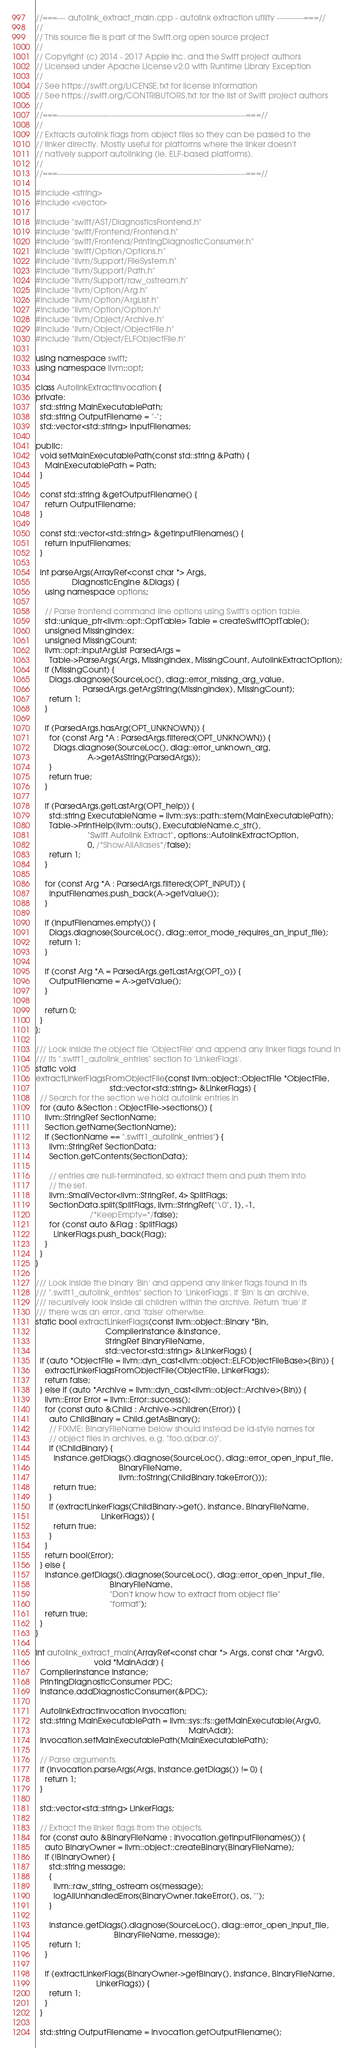Convert code to text. <code><loc_0><loc_0><loc_500><loc_500><_C++_>//===--- autolink_extract_main.cpp - autolink extraction utility ----------===//
//
// This source file is part of the Swift.org open source project
//
// Copyright (c) 2014 - 2017 Apple Inc. and the Swift project authors
// Licensed under Apache License v2.0 with Runtime Library Exception
//
// See https://swift.org/LICENSE.txt for license information
// See https://swift.org/CONTRIBUTORS.txt for the list of Swift project authors
//
//===----------------------------------------------------------------------===//
//
// Extracts autolink flags from object files so they can be passed to the
// linker directly. Mostly useful for platforms where the linker doesn't
// natively support autolinking (ie. ELF-based platforms).
//
//===----------------------------------------------------------------------===//

#include <string>
#include <vector>

#include "swift/AST/DiagnosticsFrontend.h"
#include "swift/Frontend/Frontend.h"
#include "swift/Frontend/PrintingDiagnosticConsumer.h"
#include "swift/Option/Options.h"
#include "llvm/Support/FileSystem.h"
#include "llvm/Support/Path.h"
#include "llvm/Support/raw_ostream.h"
#include "llvm/Option/Arg.h"
#include "llvm/Option/ArgList.h"
#include "llvm/Option/Option.h"
#include "llvm/Object/Archive.h"
#include "llvm/Object/ObjectFile.h"
#include "llvm/Object/ELFObjectFile.h"

using namespace swift;
using namespace llvm::opt;

class AutolinkExtractInvocation {
private:
  std::string MainExecutablePath;
  std::string OutputFilename = "-";
  std::vector<std::string> InputFilenames;

public:
  void setMainExecutablePath(const std::string &Path) {
    MainExecutablePath = Path;
  }

  const std::string &getOutputFilename() {
    return OutputFilename;
  }

  const std::vector<std::string> &getInputFilenames() {
    return InputFilenames;
  }

  int parseArgs(ArrayRef<const char *> Args,
                DiagnosticEngine &Diags) {
    using namespace options;

    // Parse frontend command line options using Swift's option table.
    std::unique_ptr<llvm::opt::OptTable> Table = createSwiftOptTable();
    unsigned MissingIndex;
    unsigned MissingCount;
    llvm::opt::InputArgList ParsedArgs =
      Table->ParseArgs(Args, MissingIndex, MissingCount, AutolinkExtractOption);
    if (MissingCount) {
      Diags.diagnose(SourceLoc(), diag::error_missing_arg_value,
                     ParsedArgs.getArgString(MissingIndex), MissingCount);
      return 1;
    }

    if (ParsedArgs.hasArg(OPT_UNKNOWN)) {
      for (const Arg *A : ParsedArgs.filtered(OPT_UNKNOWN)) {
        Diags.diagnose(SourceLoc(), diag::error_unknown_arg,
                       A->getAsString(ParsedArgs));
      }
      return true;
    }

    if (ParsedArgs.getLastArg(OPT_help)) {
      std::string ExecutableName = llvm::sys::path::stem(MainExecutablePath);
      Table->PrintHelp(llvm::outs(), ExecutableName.c_str(),
                       "Swift Autolink Extract", options::AutolinkExtractOption,
                       0, /*ShowAllAliases*/false);
      return 1;
    }

    for (const Arg *A : ParsedArgs.filtered(OPT_INPUT)) {
      InputFilenames.push_back(A->getValue());
    }

    if (InputFilenames.empty()) {
      Diags.diagnose(SourceLoc(), diag::error_mode_requires_an_input_file);
      return 1;
    }

    if (const Arg *A = ParsedArgs.getLastArg(OPT_o)) {
      OutputFilename = A->getValue();
    }

    return 0;
  }
};

/// Look inside the object file 'ObjectFile' and append any linker flags found in
/// its ".swift1_autolink_entries" section to 'LinkerFlags'.
static void
extractLinkerFlagsFromObjectFile(const llvm::object::ObjectFile *ObjectFile,
                                 std::vector<std::string> &LinkerFlags) {
  // Search for the section we hold autolink entries in
  for (auto &Section : ObjectFile->sections()) {
    llvm::StringRef SectionName;
    Section.getName(SectionName);
    if (SectionName == ".swift1_autolink_entries") {
      llvm::StringRef SectionData;
      Section.getContents(SectionData);

      // entries are null-terminated, so extract them and push them into
      // the set.
      llvm::SmallVector<llvm::StringRef, 4> SplitFlags;
      SectionData.split(SplitFlags, llvm::StringRef("\0", 1), -1,
                        /*KeepEmpty=*/false);
      for (const auto &Flag : SplitFlags)
        LinkerFlags.push_back(Flag);
    }
  }
}

/// Look inside the binary 'Bin' and append any linker flags found in its
/// ".swift1_autolink_entries" section to 'LinkerFlags'. If 'Bin' is an archive,
/// recursively look inside all children within the archive. Return 'true' if
/// there was an error, and 'false' otherwise.
static bool extractLinkerFlags(const llvm::object::Binary *Bin,
                               CompilerInstance &Instance,
                               StringRef BinaryFileName,
                               std::vector<std::string> &LinkerFlags) {
  if (auto *ObjectFile = llvm::dyn_cast<llvm::object::ELFObjectFileBase>(Bin)) {
    extractLinkerFlagsFromObjectFile(ObjectFile, LinkerFlags);
    return false;
  } else if (auto *Archive = llvm::dyn_cast<llvm::object::Archive>(Bin)) {
    llvm::Error Error = llvm::Error::success();
    for (const auto &Child : Archive->children(Error)) {
      auto ChildBinary = Child.getAsBinary();
      // FIXME: BinaryFileName below should instead be ld-style names for
      // object files in archives, e.g. "foo.a(bar.o)".
      if (!ChildBinary) {
        Instance.getDiags().diagnose(SourceLoc(), diag::error_open_input_file,
                                     BinaryFileName,
                                     llvm::toString(ChildBinary.takeError()));
        return true;
      }
      if (extractLinkerFlags(ChildBinary->get(), Instance, BinaryFileName,
                             LinkerFlags)) {
        return true;
      }
    }
    return bool(Error);
  } else {
    Instance.getDiags().diagnose(SourceLoc(), diag::error_open_input_file,
                                 BinaryFileName,
                                 "Don't know how to extract from object file"
                                 "format");
    return true;
  }
}

int autolink_extract_main(ArrayRef<const char *> Args, const char *Argv0,
                          void *MainAddr) {
  CompilerInstance Instance;
  PrintingDiagnosticConsumer PDC;
  Instance.addDiagnosticConsumer(&PDC);

  AutolinkExtractInvocation Invocation;
  std::string MainExecutablePath = llvm::sys::fs::getMainExecutable(Argv0,
                                                                    MainAddr);
  Invocation.setMainExecutablePath(MainExecutablePath);

  // Parse arguments.
  if (Invocation.parseArgs(Args, Instance.getDiags()) != 0) {
    return 1;
  }

  std::vector<std::string> LinkerFlags;

  // Extract the linker flags from the objects.
  for (const auto &BinaryFileName : Invocation.getInputFilenames()) {
    auto BinaryOwner = llvm::object::createBinary(BinaryFileName);
    if (!BinaryOwner) {
      std::string message;
      {
        llvm::raw_string_ostream os(message);
        logAllUnhandledErrors(BinaryOwner.takeError(), os, "");
      }

      Instance.getDiags().diagnose(SourceLoc(), diag::error_open_input_file,
                                   BinaryFileName, message);
      return 1;
    }

    if (extractLinkerFlags(BinaryOwner->getBinary(), Instance, BinaryFileName,
                           LinkerFlags)) {
      return 1;
    }
  }

  std::string OutputFilename = Invocation.getOutputFilename();</code> 